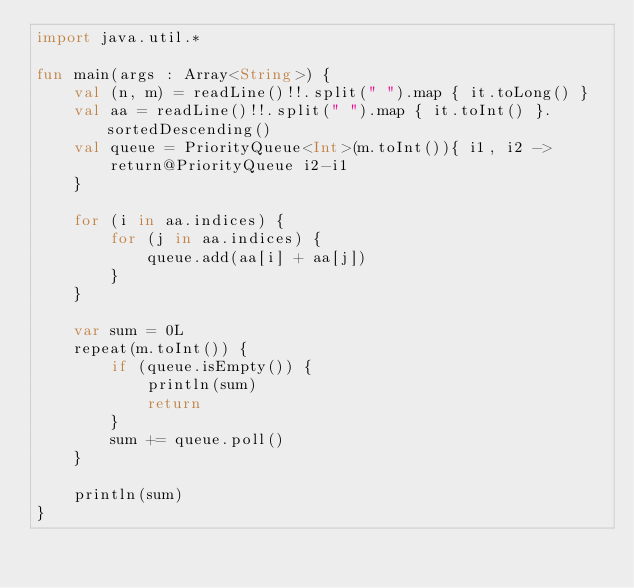<code> <loc_0><loc_0><loc_500><loc_500><_Kotlin_>import java.util.*

fun main(args : Array<String>) {
    val (n, m) = readLine()!!.split(" ").map { it.toLong() }
    val aa = readLine()!!.split(" ").map { it.toInt() }.sortedDescending()
    val queue = PriorityQueue<Int>(m.toInt()){ i1, i2 ->
        return@PriorityQueue i2-i1
    }

    for (i in aa.indices) {
        for (j in aa.indices) {
            queue.add(aa[i] + aa[j])
        }
    }

    var sum = 0L
    repeat(m.toInt()) {
        if (queue.isEmpty()) {
            println(sum)
            return
        }
        sum += queue.poll()
    }

    println(sum)
}</code> 